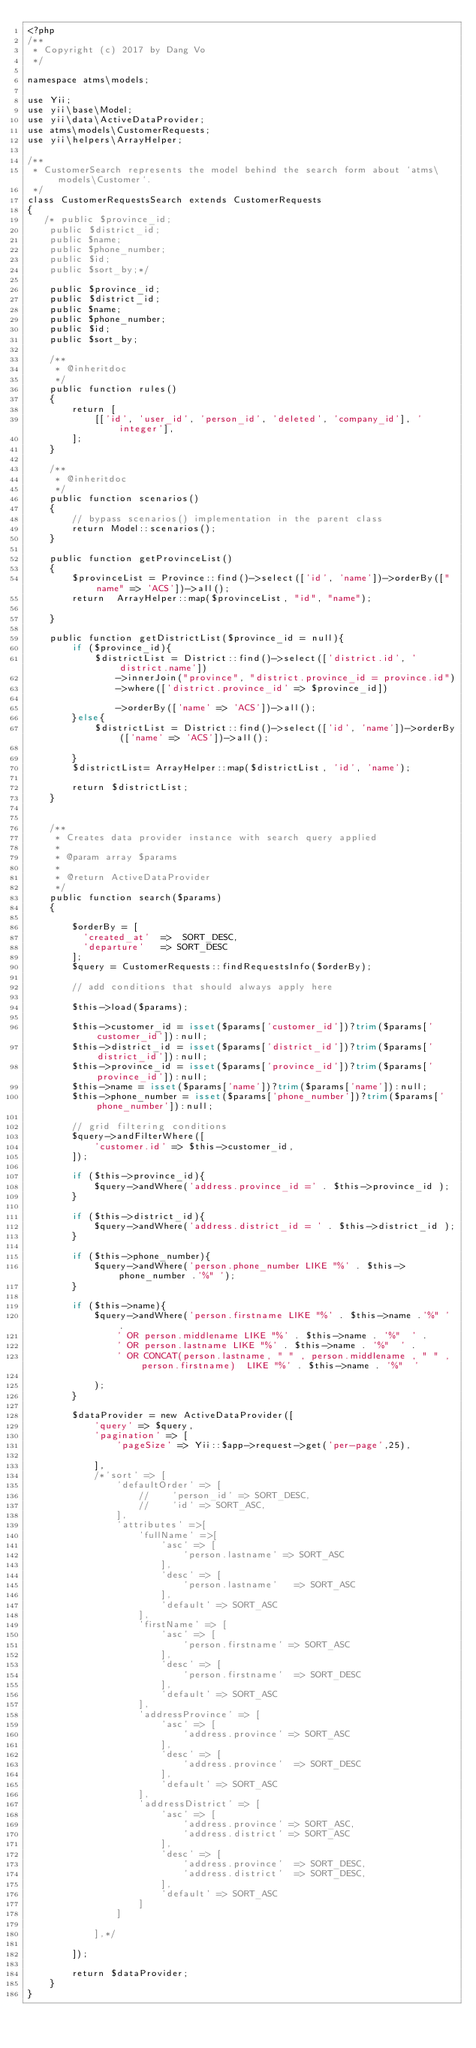Convert code to text. <code><loc_0><loc_0><loc_500><loc_500><_PHP_><?php
/**
 * Copyright (c) 2017 by Dang Vo
 */

namespace atms\models;

use Yii;
use yii\base\Model;
use yii\data\ActiveDataProvider;
use atms\models\CustomerRequests;
use yii\helpers\ArrayHelper;

/**
 * CustomerSearch represents the model behind the search form about `atms\models\Customer`.
 */
class CustomerRequestsSearch extends CustomerRequests
{
   /* public $province_id;
    public $district_id;
    public $name;
    public $phone_number;
    public $id;
    public $sort_by;*/

    public $province_id;
    public $district_id;
    public $name;
    public $phone_number;
    public $id;
    public $sort_by;

    /**
     * @inheritdoc
     */
    public function rules()
    {
        return [
            [['id', 'user_id', 'person_id', 'deleted', 'company_id'], 'integer'],
        ];
    }

    /**
     * @inheritdoc
     */
    public function scenarios()
    {
        // bypass scenarios() implementation in the parent class
        return Model::scenarios();
    }

    public function getProvinceList()
    {
        $provinceList = Province::find()->select(['id', 'name'])->orderBy(["name" => 'ACS'])->all();
        return  ArrayHelper::map($provinceList, "id", "name");

    }

    public function getDistrictList($province_id = null){
        if ($province_id){
            $districtList = District::find()->select(['district.id', 'district.name'])
                ->innerJoin("province", "district.province_id = province.id")
                ->where(['district.province_id' => $province_id])

                ->orderBy(['name' => 'ACS'])->all();
        }else{
            $districtList = District::find()->select(['id', 'name'])->orderBy(['name' => 'ACS'])->all();

        }
        $districtList= ArrayHelper::map($districtList, 'id', 'name');

        return $districtList;
    }


    /**
     * Creates data provider instance with search query applied
     *
     * @param array $params
     *
     * @return ActiveDataProvider
     */
    public function search($params)
    {

        $orderBy = [
          'created_at'  =>  SORT_DESC,
          'departure'   => SORT_DESC
        ];
        $query = CustomerRequests::findRequestsInfo($orderBy);

        // add conditions that should always apply here

        $this->load($params);

        $this->customer_id = isset($params['customer_id'])?trim($params['customer_id']):null;
        $this->district_id = isset($params['district_id'])?trim($params['district_id']):null;
        $this->province_id = isset($params['province_id'])?trim($params['province_id']):null;
        $this->name = isset($params['name'])?trim($params['name']):null;
        $this->phone_number = isset($params['phone_number'])?trim($params['phone_number']):null;

        // grid filtering conditions
        $query->andFilterWhere([
            'customer.id' => $this->customer_id,
        ]);

        if ($this->province_id){
            $query->andWhere('address.province_id =' . $this->province_id );
        }

        if ($this->district_id){
            $query->andWhere('address.district_id = ' . $this->district_id );
        }

        if ($this->phone_number){
            $query->andWhere('person.phone_number LIKE "%' . $this->phone_number .'%" ');
        }

        if ($this->name){
            $query->andWhere('person.firstname LIKE "%' . $this->name .'%" ' .
                ' OR person.middlename LIKE "%' . $this->name . '%"  ' .
                ' OR person.lastname LIKE "%' . $this->name . '%"  ' .
                ' OR CONCAT(person.lastname, " " , person.middlename , " " , person.firstname)  LIKE "%' . $this->name . '%"  '

            );
        }

        $dataProvider = new ActiveDataProvider([
            'query' => $query,
            'pagination' => [
                'pageSize' => Yii::$app->request->get('per-page',25),

            ],
            /*'sort' => [
                'defaultOrder' => [
                    //    'person_id' => SORT_DESC,
                    //    'id' => SORT_ASC,
                ],
                'attributes' =>[
                    'fullName' =>[
                        'asc' => [
                            'person.lastname' => SORT_ASC
                        ],
                        'desc' => [
                            'person.lastname'   => SORT_ASC
                        ],
                        'default' => SORT_ASC
                    ],
                    'firstName' => [
                        'asc' => [
                            'person.firstname' => SORT_ASC
                        ],
                        'desc' => [
                            'person.firstname'  => SORT_DESC
                        ],
                        'default' => SORT_ASC
                    ],
                    'addressProvince' => [
                        'asc' => [
                            'address.province' => SORT_ASC
                        ],
                        'desc' => [
                            'address.province'  => SORT_DESC
                        ],
                        'default' => SORT_ASC
                    ],
                    'addressDistrict' => [
                        'asc' => [
                            'address.province' => SORT_ASC,
                            'address.district' => SORT_ASC
                        ],
                        'desc' => [
                            'address.province'  => SORT_DESC,
                            'address.district'  => SORT_DESC,
                        ],
                        'default' => SORT_ASC
                    ]
                ]

            ],*/

        ]);

        return $dataProvider;
    }
}
</code> 